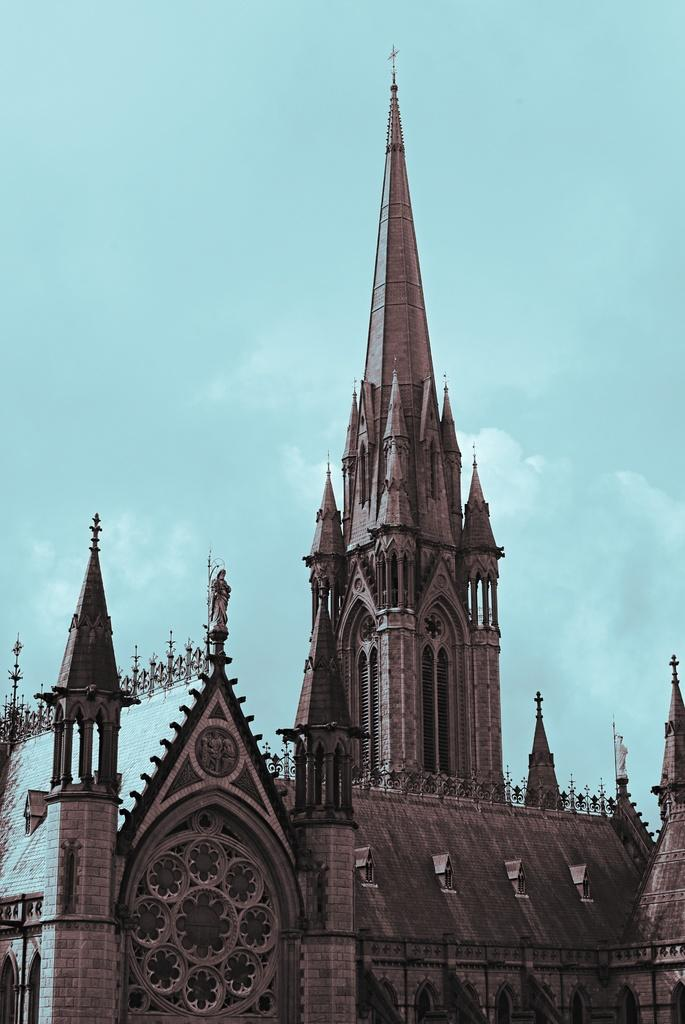What is the main structure in the image? There is a building in the image. What feature can be seen on the building? The building has windows. What is visible in the background of the image? The sky is visible in the image. How would you describe the weather based on the sky? The sky appears to be cloudy, which might suggest overcast or potentially rainy weather. What type of pie is being offered by the judge in the image? There is no pie or judge present in the image; it only features a building and a cloudy sky. 